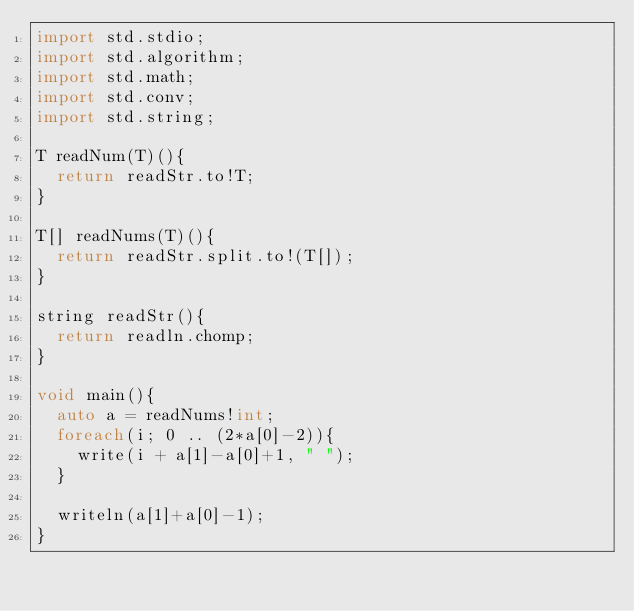Convert code to text. <code><loc_0><loc_0><loc_500><loc_500><_D_>import std.stdio;
import std.algorithm;
import std.math;
import std.conv;
import std.string;

T readNum(T)(){
  return readStr.to!T;
}

T[] readNums(T)(){
  return readStr.split.to!(T[]);
}

string readStr(){
  return readln.chomp;
}

void main(){
  auto a = readNums!int;
  foreach(i; 0 .. (2*a[0]-2)){
    write(i + a[1]-a[0]+1, " ");
  }

  writeln(a[1]+a[0]-1);
}
</code> 